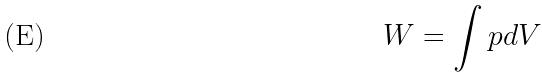Convert formula to latex. <formula><loc_0><loc_0><loc_500><loc_500>W = \int p d V</formula> 